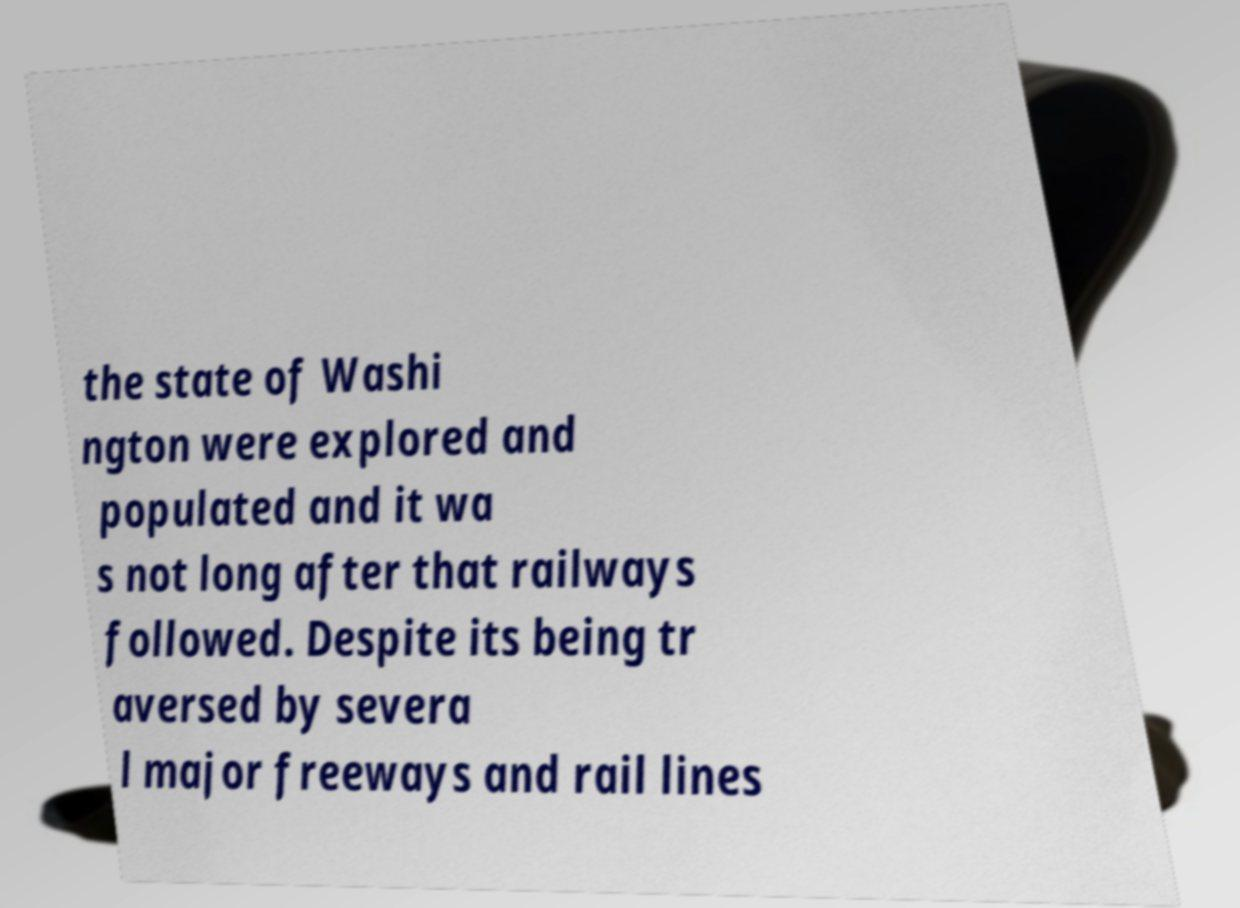I need the written content from this picture converted into text. Can you do that? the state of Washi ngton were explored and populated and it wa s not long after that railways followed. Despite its being tr aversed by severa l major freeways and rail lines 